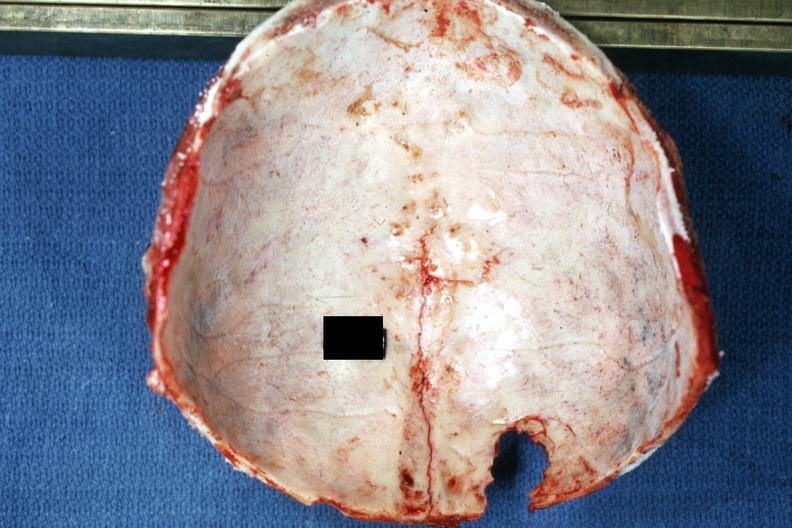what is present?
Answer the question using a single word or phrase. Linear fracture in occiput 